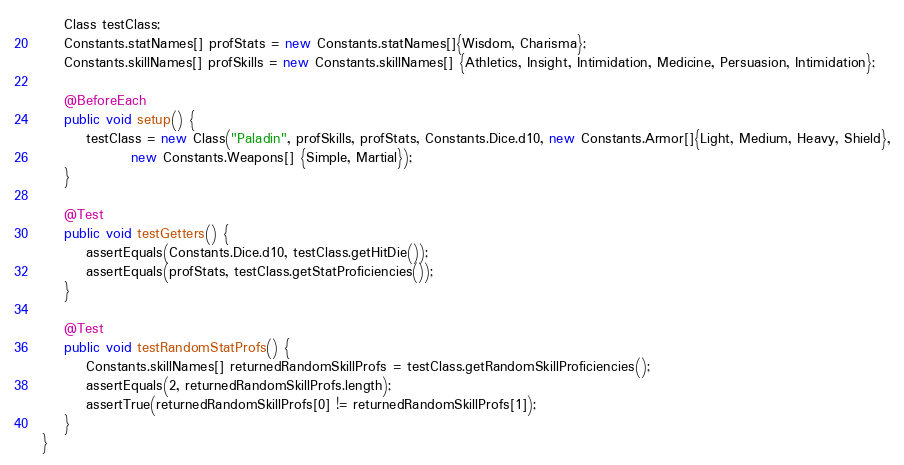Convert code to text. <code><loc_0><loc_0><loc_500><loc_500><_Java_>    Class testClass;
    Constants.statNames[] profStats = new Constants.statNames[]{Wisdom, Charisma};
    Constants.skillNames[] profSkills = new Constants.skillNames[] {Athletics, Insight, Intimidation, Medicine, Persuasion, Intimidation};

    @BeforeEach
    public void setup() {
        testClass = new Class("Paladin", profSkills, profStats, Constants.Dice.d10, new Constants.Armor[]{Light, Medium, Heavy, Shield},
                new Constants.Weapons[] {Simple, Martial});
    }

    @Test
    public void testGetters() {
        assertEquals(Constants.Dice.d10, testClass.getHitDie());
        assertEquals(profStats, testClass.getStatProficiencies());
    }

    @Test
    public void testRandomStatProfs() {
        Constants.skillNames[] returnedRandomSkillProfs = testClass.getRandomSkillProficiencies();
        assertEquals(2, returnedRandomSkillProfs.length);
        assertTrue(returnedRandomSkillProfs[0] != returnedRandomSkillProfs[1]);
    }
}
</code> 